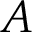Convert formula to latex. <formula><loc_0><loc_0><loc_500><loc_500>A</formula> 